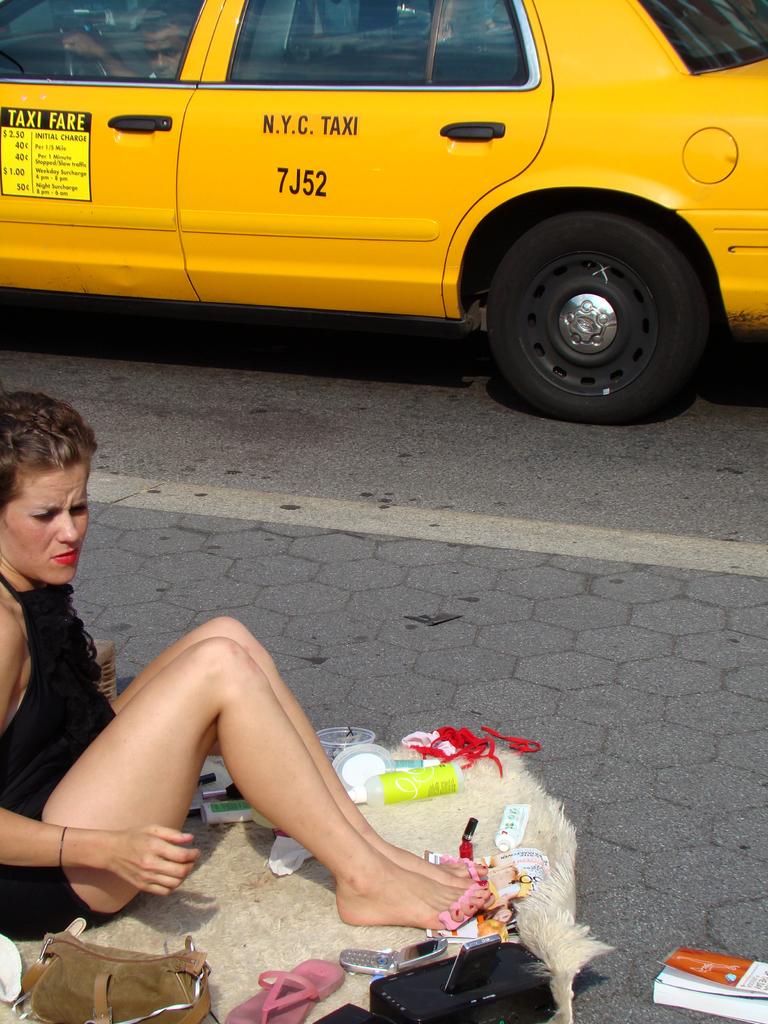What number taxi is this?
Provide a short and direct response. 7j52. Which city does this vehicle operate out of?
Keep it short and to the point. New york city. 